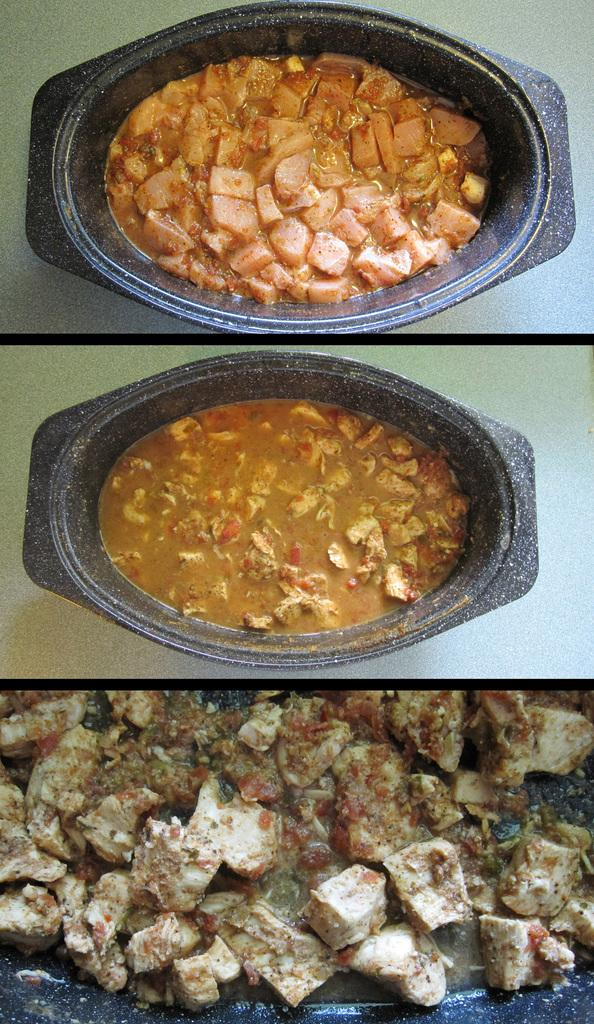What types of food are shown in the image? There are different curries in the image. What color is the bowl containing the curries? The bowl is black in color. What is the format of the image in the picture? There is a collage image in the picture. How many tomatoes are visible in the image? There are no tomatoes visible in the image; it features different curries in a black bowl and a collage image. What type of clothing is shown in the image? There is no clothing, such as a vest, present in the image. 